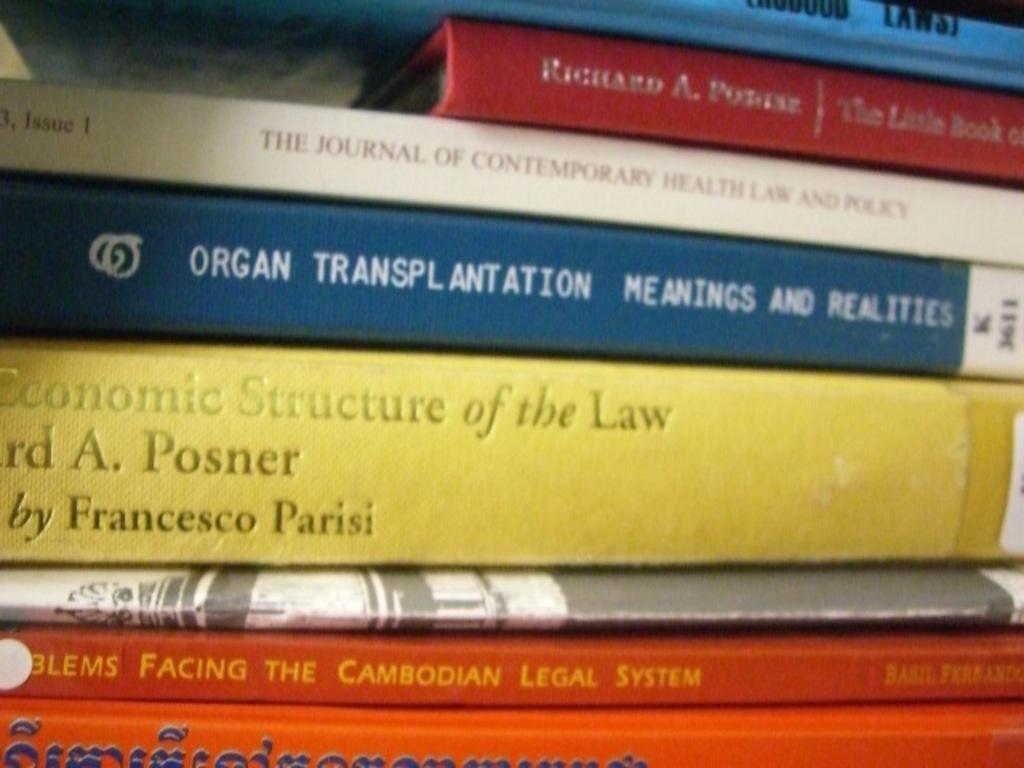Who is the author of the yellow book?
Your response must be concise. Francesco parisi. 